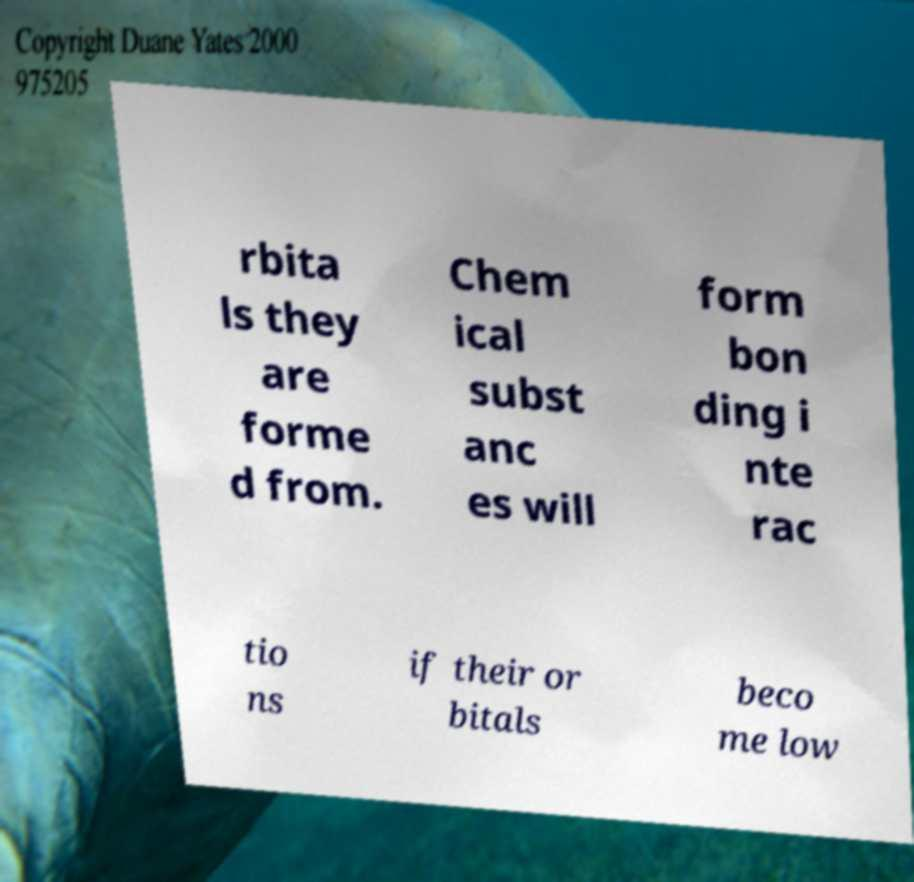What messages or text are displayed in this image? I need them in a readable, typed format. rbita ls they are forme d from. Chem ical subst anc es will form bon ding i nte rac tio ns if their or bitals beco me low 